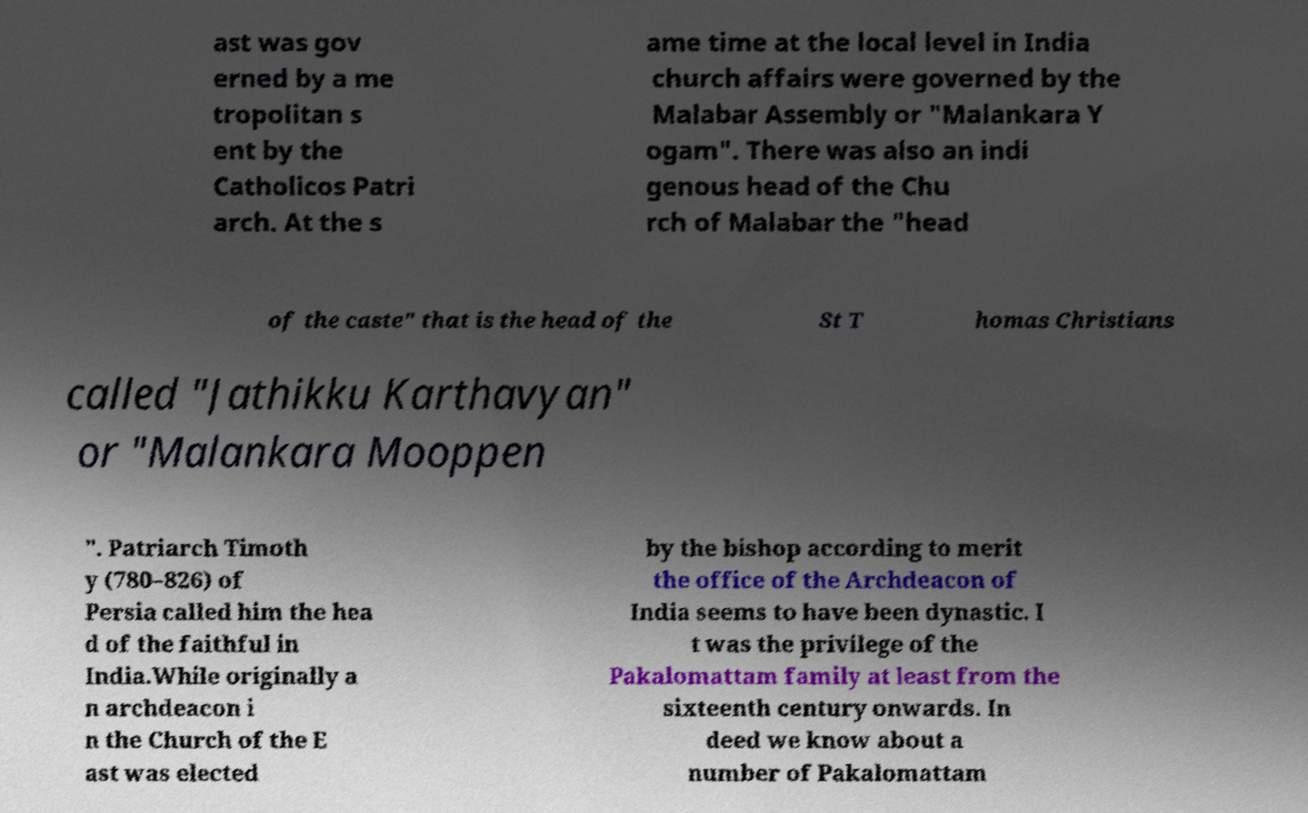I need the written content from this picture converted into text. Can you do that? ast was gov erned by a me tropolitan s ent by the Catholicos Patri arch. At the s ame time at the local level in India church affairs were governed by the Malabar Assembly or "Malankara Y ogam". There was also an indi genous head of the Chu rch of Malabar the "head of the caste" that is the head of the St T homas Christians called "Jathikku Karthavyan" or "Malankara Mooppen ". Patriarch Timoth y (780–826) of Persia called him the hea d of the faithful in India.While originally a n archdeacon i n the Church of the E ast was elected by the bishop according to merit the office of the Archdeacon of India seems to have been dynastic. I t was the privilege of the Pakalomattam family at least from the sixteenth century onwards. In deed we know about a number of Pakalomattam 